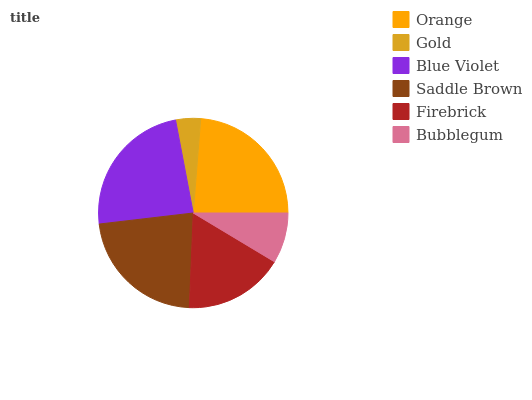Is Gold the minimum?
Answer yes or no. Yes. Is Blue Violet the maximum?
Answer yes or no. Yes. Is Blue Violet the minimum?
Answer yes or no. No. Is Gold the maximum?
Answer yes or no. No. Is Blue Violet greater than Gold?
Answer yes or no. Yes. Is Gold less than Blue Violet?
Answer yes or no. Yes. Is Gold greater than Blue Violet?
Answer yes or no. No. Is Blue Violet less than Gold?
Answer yes or no. No. Is Saddle Brown the high median?
Answer yes or no. Yes. Is Firebrick the low median?
Answer yes or no. Yes. Is Bubblegum the high median?
Answer yes or no. No. Is Bubblegum the low median?
Answer yes or no. No. 